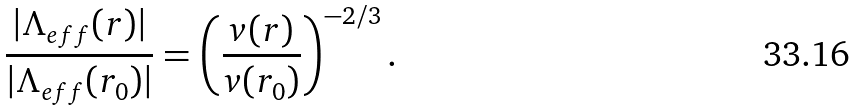<formula> <loc_0><loc_0><loc_500><loc_500>\frac { | \Lambda _ { e f f } ( r ) | } { | \Lambda _ { e f f } ( r _ { 0 } ) | } = \left ( \frac { v ( r ) } { v ( r _ { 0 } ) } \right ) ^ { - 2 / 3 } .</formula> 